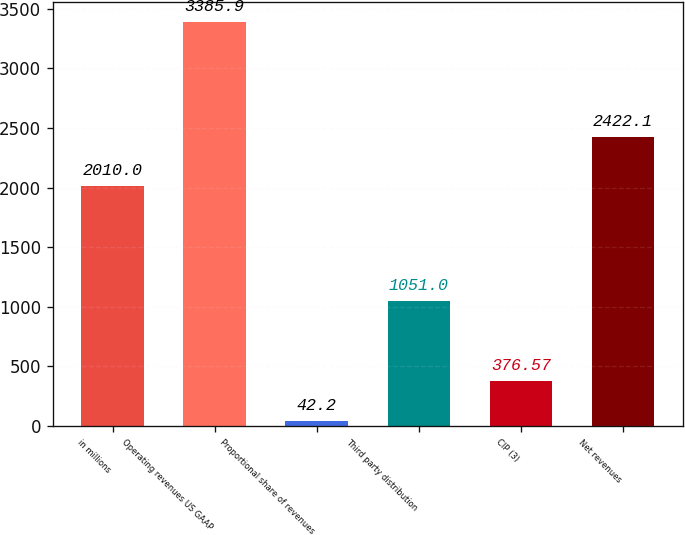Convert chart. <chart><loc_0><loc_0><loc_500><loc_500><bar_chart><fcel>in millions<fcel>Operating revenues US GAAP<fcel>Proportional share of revenues<fcel>Third party distribution<fcel>CIP (3)<fcel>Net revenues<nl><fcel>2010<fcel>3385.9<fcel>42.2<fcel>1051<fcel>376.57<fcel>2422.1<nl></chart> 